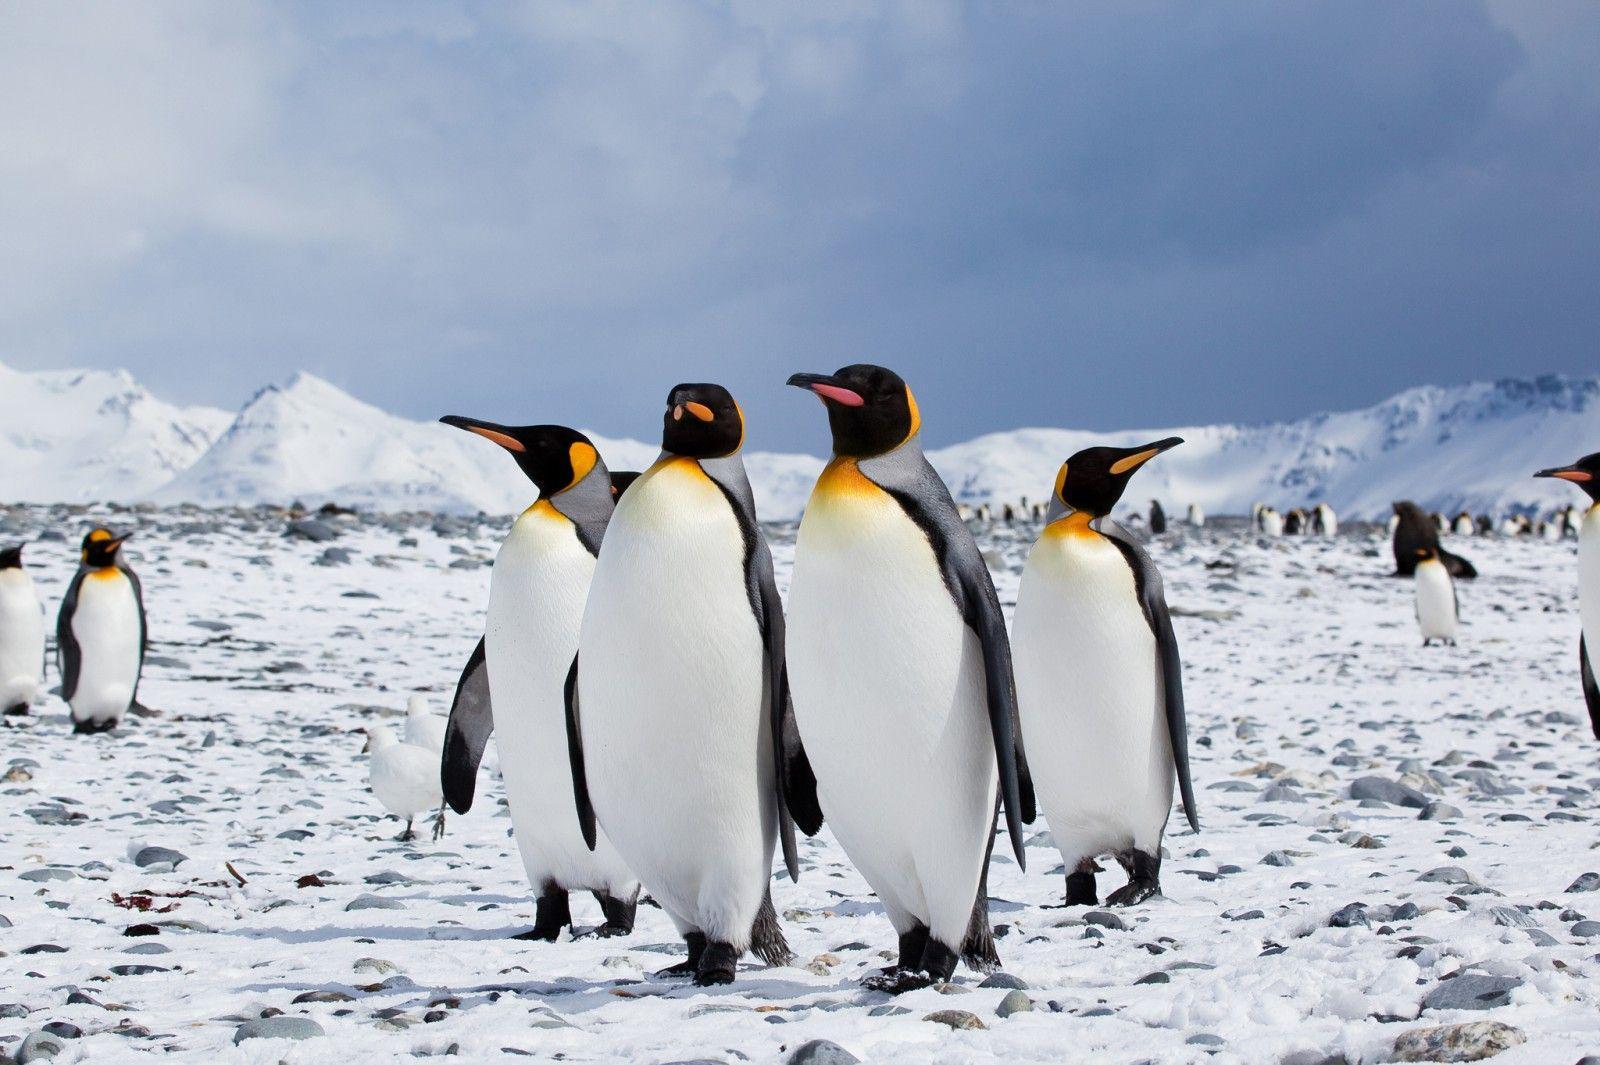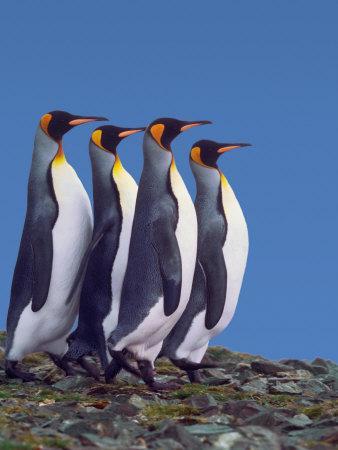The first image is the image on the left, the second image is the image on the right. Analyze the images presented: Is the assertion "One image has one penguin flexing its wings away from its body while its head is facing upwards." valid? Answer yes or no. No. The first image is the image on the left, the second image is the image on the right. Examine the images to the left and right. Is the description "There are three or fewer penguins in total." accurate? Answer yes or no. No. The first image is the image on the left, the second image is the image on the right. Given the left and right images, does the statement "One of the images shows a single penguin standing on two legs and facing the left." hold true? Answer yes or no. No. 